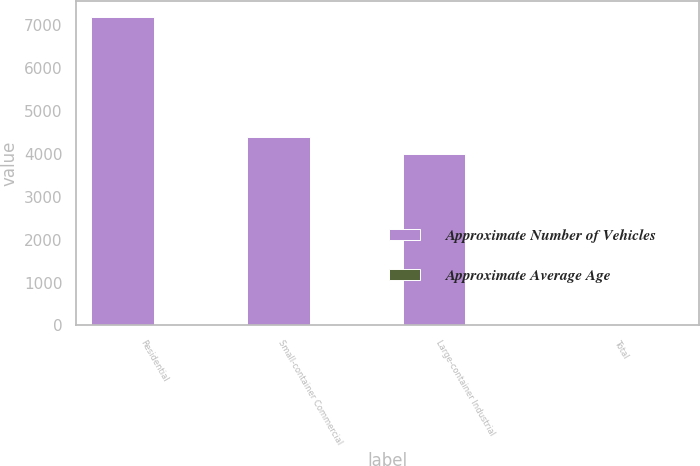Convert chart. <chart><loc_0><loc_0><loc_500><loc_500><stacked_bar_chart><ecel><fcel>Residential<fcel>Small-container Commercial<fcel>Large-container Industrial<fcel>Total<nl><fcel>Approximate Number of Vehicles<fcel>7200<fcel>4400<fcel>4000<fcel>9<nl><fcel>Approximate Average Age<fcel>7<fcel>7<fcel>9<fcel>7.5<nl></chart> 